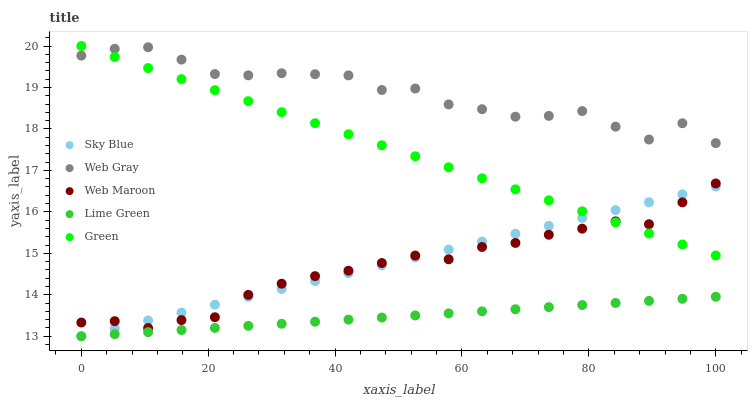Does Lime Green have the minimum area under the curve?
Answer yes or no. Yes. Does Web Gray have the maximum area under the curve?
Answer yes or no. Yes. Does Web Maroon have the minimum area under the curve?
Answer yes or no. No. Does Web Maroon have the maximum area under the curve?
Answer yes or no. No. Is Sky Blue the smoothest?
Answer yes or no. Yes. Is Web Gray the roughest?
Answer yes or no. Yes. Is Web Maroon the smoothest?
Answer yes or no. No. Is Web Maroon the roughest?
Answer yes or no. No. Does Sky Blue have the lowest value?
Answer yes or no. Yes. Does Web Maroon have the lowest value?
Answer yes or no. No. Does Green have the highest value?
Answer yes or no. Yes. Does Web Gray have the highest value?
Answer yes or no. No. Is Web Maroon less than Web Gray?
Answer yes or no. Yes. Is Web Gray greater than Sky Blue?
Answer yes or no. Yes. Does Green intersect Web Maroon?
Answer yes or no. Yes. Is Green less than Web Maroon?
Answer yes or no. No. Is Green greater than Web Maroon?
Answer yes or no. No. Does Web Maroon intersect Web Gray?
Answer yes or no. No. 